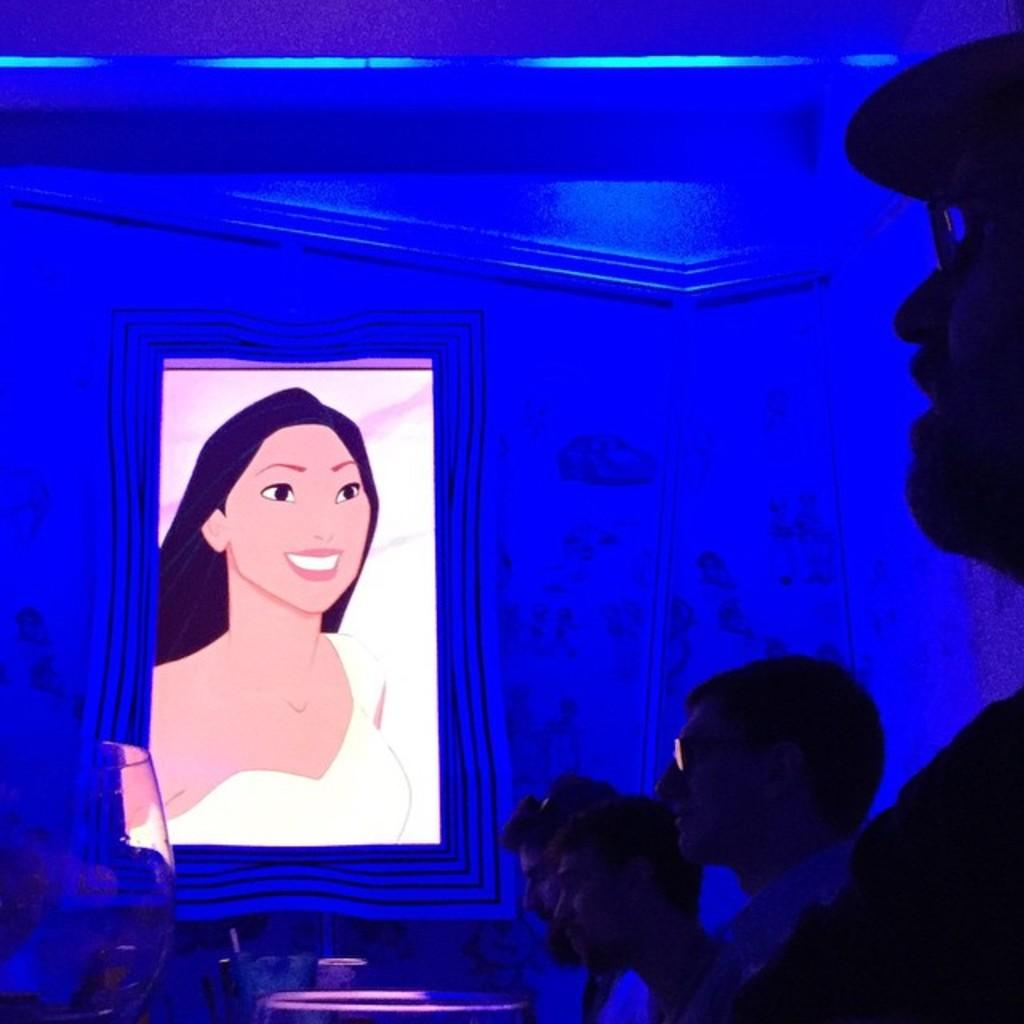What can be seen on the right side of the image? There are people on the right side of the image. What is the main object in the center of the image? There is a photo frame of a lady in the center of the image. What is visible in the background of the image? There is a wall in the background of the image. What type of writing is visible on the photo frame in the image? There is no writing visible on the photo frame in the image. What instrument is the lady holding in the photo frame? The lady in the photo frame is not holding any instrument; she is simply depicted in the frame. 